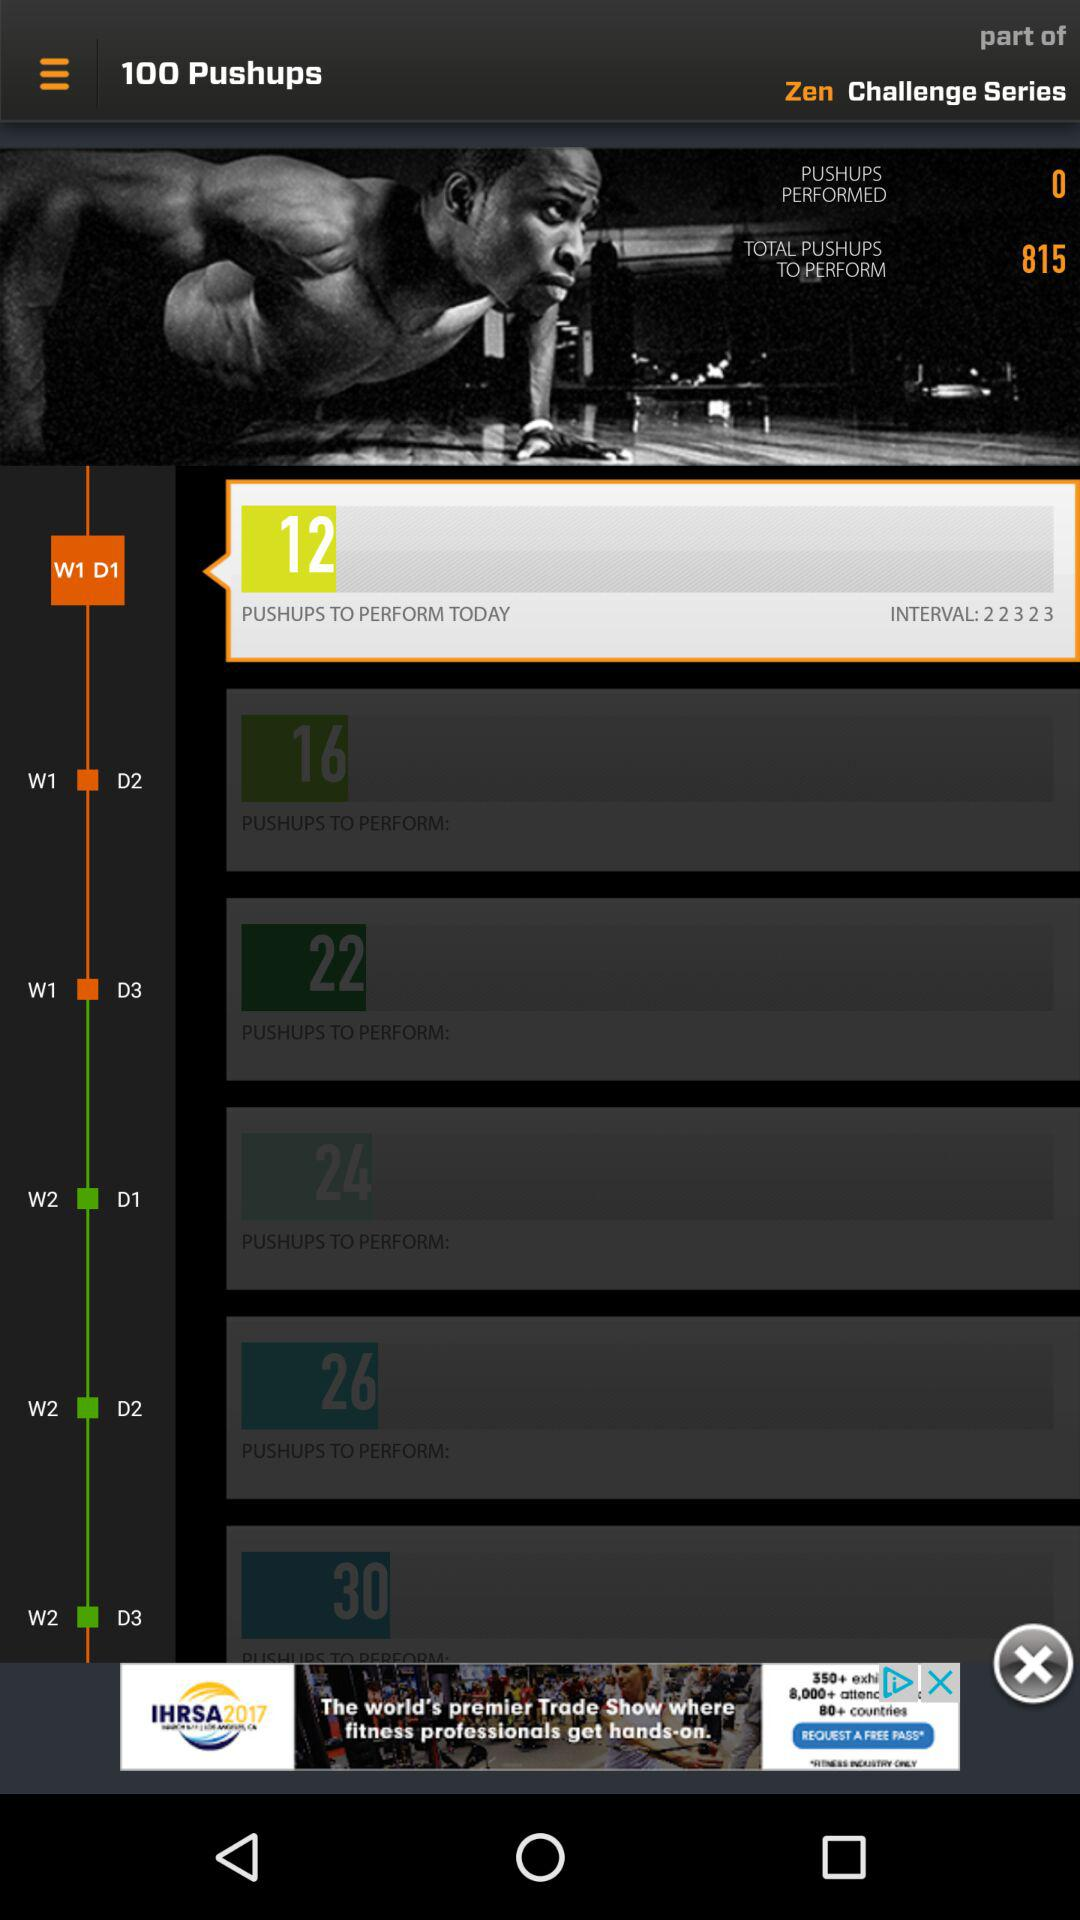How many pushups are to be performed today? The pushups to be performed today are 12. 